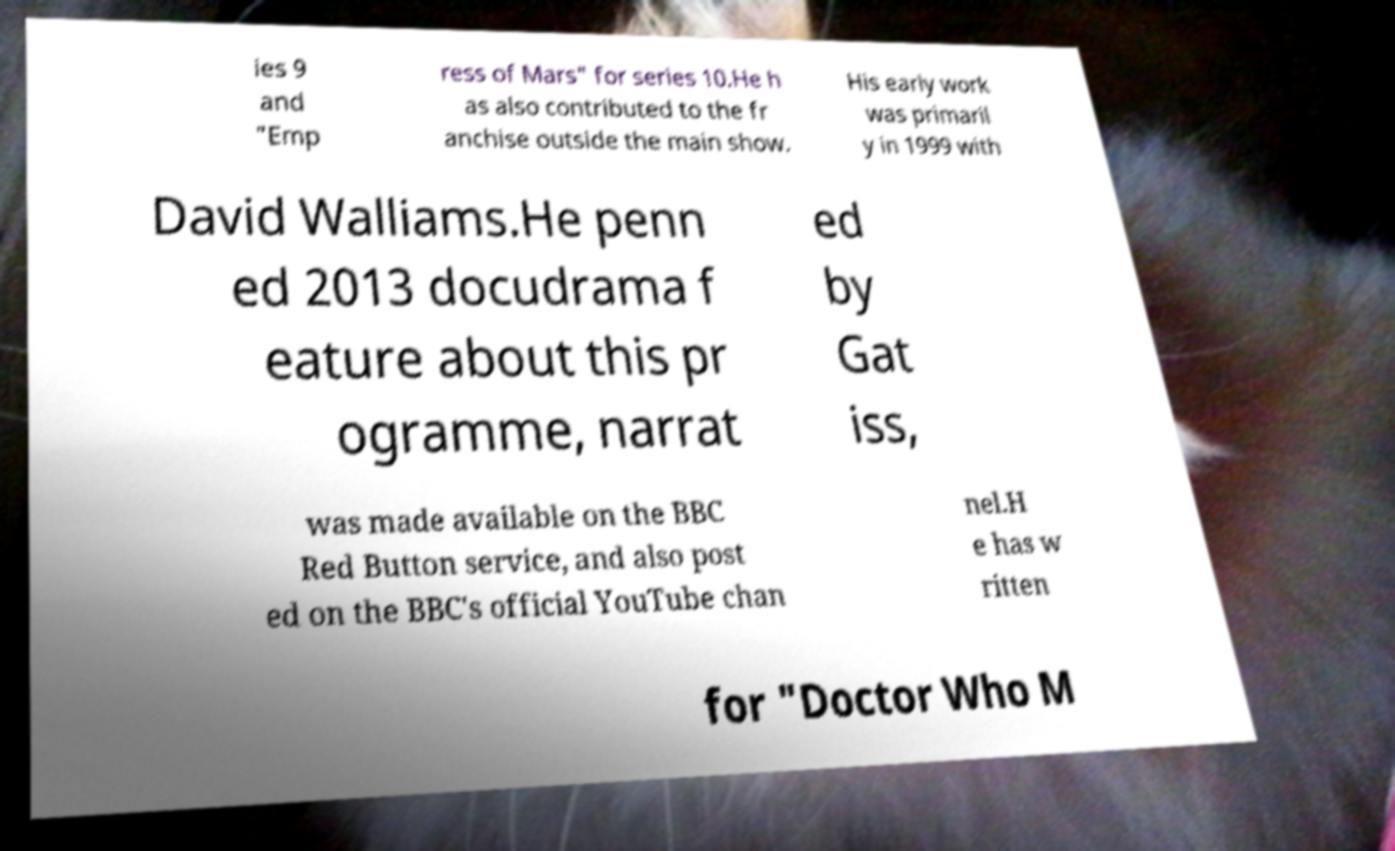What messages or text are displayed in this image? I need them in a readable, typed format. ies 9 and "Emp ress of Mars" for series 10.He h as also contributed to the fr anchise outside the main show. His early work was primaril y in 1999 with David Walliams.He penn ed 2013 docudrama f eature about this pr ogramme, narrat ed by Gat iss, was made available on the BBC Red Button service, and also post ed on the BBC's official YouTube chan nel.H e has w ritten for "Doctor Who M 